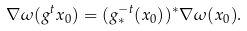Convert formula to latex. <formula><loc_0><loc_0><loc_500><loc_500>\nabla \omega ( g ^ { t } x _ { 0 } ) = ( g ^ { - t } _ { * } ( x _ { 0 } ) ) ^ { * } \nabla \omega ( x _ { 0 } ) .</formula> 